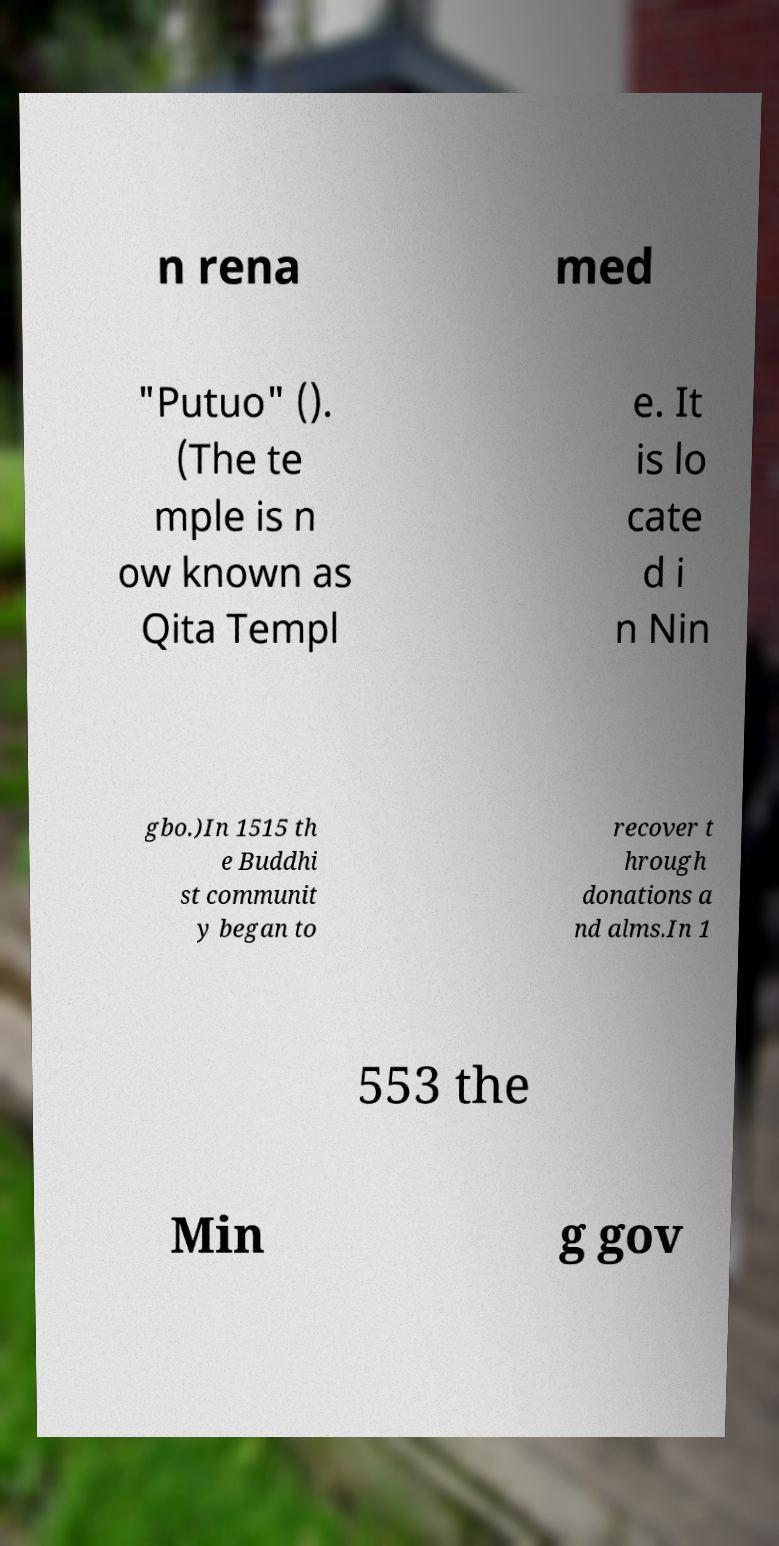Could you extract and type out the text from this image? n rena med "Putuo" (). (The te mple is n ow known as Qita Templ e. It is lo cate d i n Nin gbo.)In 1515 th e Buddhi st communit y began to recover t hrough donations a nd alms.In 1 553 the Min g gov 